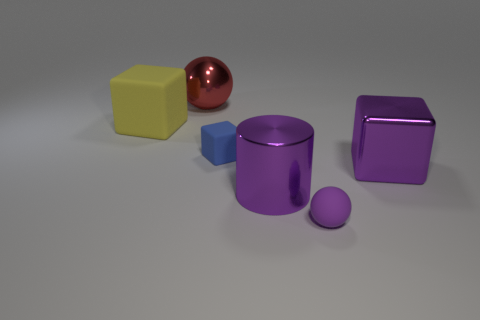Is the color of the small rubber sphere the same as the big metal sphere?
Keep it short and to the point. No. Are there fewer purple matte balls than tiny purple rubber blocks?
Make the answer very short. No. What material is the purple cylinder to the right of the blue rubber block?
Give a very brief answer. Metal. What is the material of the cylinder that is the same size as the yellow matte thing?
Your answer should be compact. Metal. What is the material of the large cube that is right of the small matte thing on the right side of the tiny object behind the large cylinder?
Offer a very short reply. Metal. Is the size of the ball that is to the left of the rubber ball the same as the tiny purple object?
Offer a very short reply. No. Are there more big purple objects than big shiny cylinders?
Provide a succinct answer. Yes. What number of large objects are either red objects or purple shiny cubes?
Offer a terse response. 2. What number of other things are there of the same color as the small ball?
Your answer should be compact. 2. How many tiny blocks have the same material as the cylinder?
Your answer should be compact. 0. 